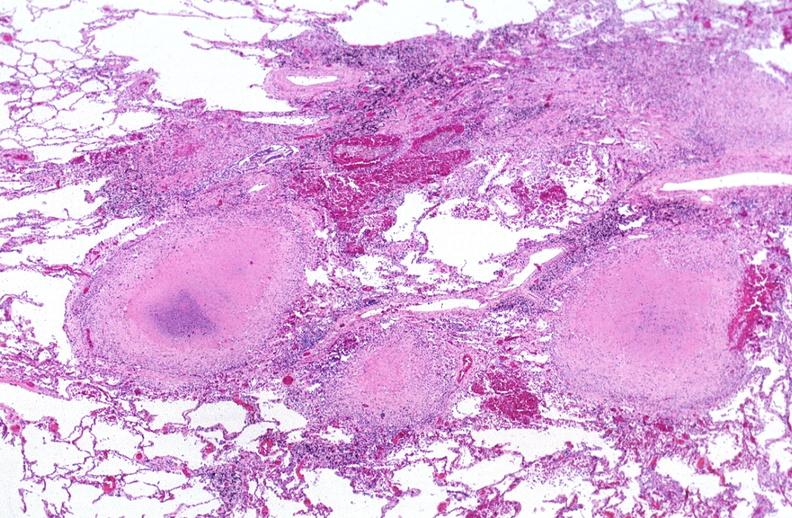where is this?
Answer the question using a single word or phrase. Lung 